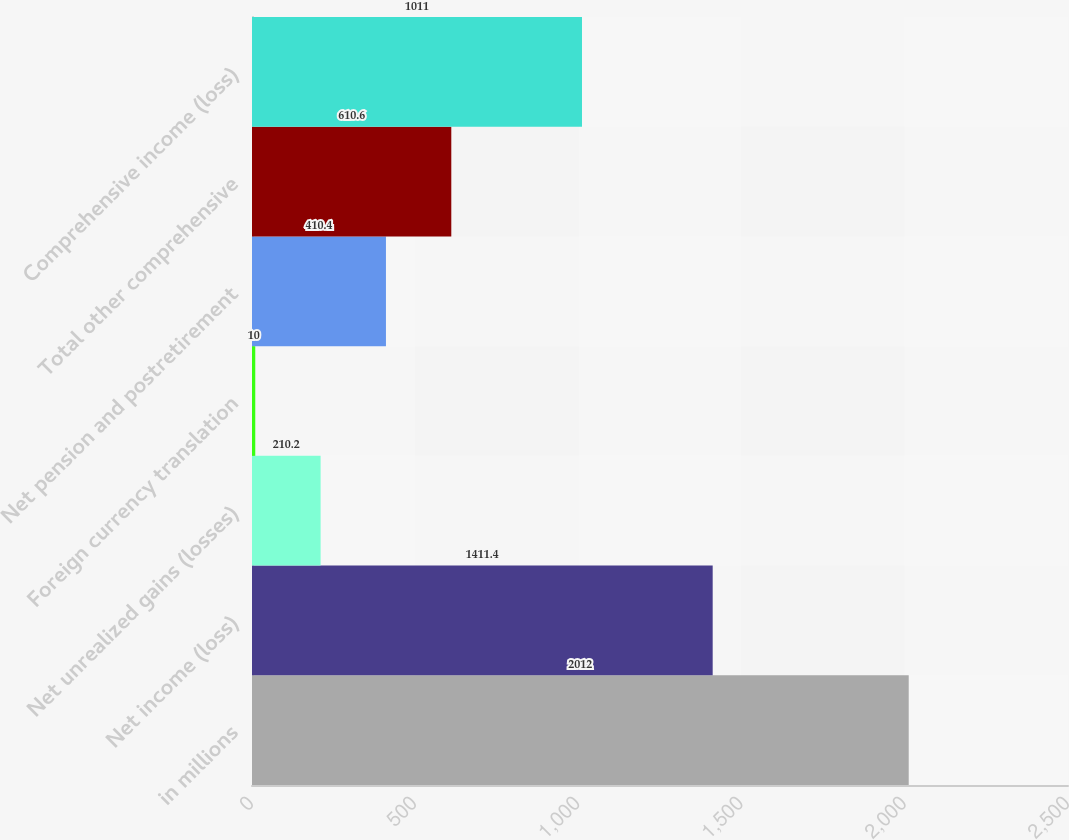Convert chart. <chart><loc_0><loc_0><loc_500><loc_500><bar_chart><fcel>in millions<fcel>Net income (loss)<fcel>Net unrealized gains (losses)<fcel>Foreign currency translation<fcel>Net pension and postretirement<fcel>Total other comprehensive<fcel>Comprehensive income (loss)<nl><fcel>2012<fcel>1411.4<fcel>210.2<fcel>10<fcel>410.4<fcel>610.6<fcel>1011<nl></chart> 